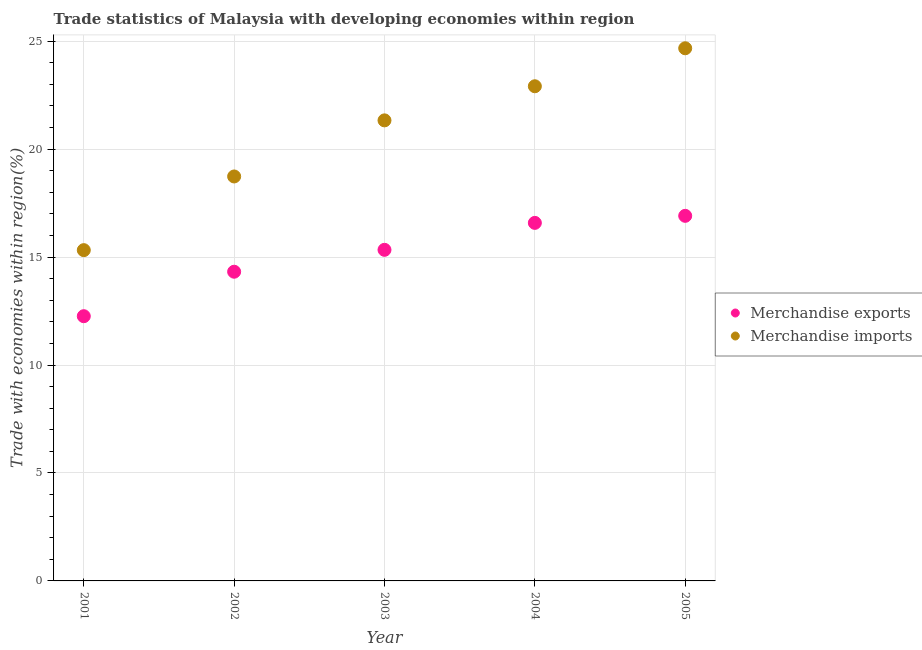Is the number of dotlines equal to the number of legend labels?
Your answer should be compact. Yes. What is the merchandise exports in 2003?
Give a very brief answer. 15.33. Across all years, what is the maximum merchandise imports?
Ensure brevity in your answer.  24.67. Across all years, what is the minimum merchandise exports?
Offer a terse response. 12.26. In which year was the merchandise imports maximum?
Provide a succinct answer. 2005. What is the total merchandise exports in the graph?
Your answer should be very brief. 75.41. What is the difference between the merchandise exports in 2002 and that in 2005?
Your answer should be very brief. -2.59. What is the difference between the merchandise imports in 2004 and the merchandise exports in 2005?
Keep it short and to the point. 6. What is the average merchandise imports per year?
Make the answer very short. 20.59. In the year 2001, what is the difference between the merchandise imports and merchandise exports?
Your answer should be compact. 3.06. What is the ratio of the merchandise exports in 2002 to that in 2004?
Provide a succinct answer. 0.86. Is the merchandise exports in 2003 less than that in 2005?
Your answer should be compact. Yes. What is the difference between the highest and the second highest merchandise exports?
Your response must be concise. 0.33. What is the difference between the highest and the lowest merchandise imports?
Provide a succinct answer. 9.35. In how many years, is the merchandise imports greater than the average merchandise imports taken over all years?
Ensure brevity in your answer.  3. Is the merchandise exports strictly greater than the merchandise imports over the years?
Provide a succinct answer. No. How many years are there in the graph?
Ensure brevity in your answer.  5. Are the values on the major ticks of Y-axis written in scientific E-notation?
Ensure brevity in your answer.  No. Does the graph contain any zero values?
Ensure brevity in your answer.  No. Where does the legend appear in the graph?
Keep it short and to the point. Center right. What is the title of the graph?
Ensure brevity in your answer.  Trade statistics of Malaysia with developing economies within region. What is the label or title of the X-axis?
Provide a short and direct response. Year. What is the label or title of the Y-axis?
Ensure brevity in your answer.  Trade with economies within region(%). What is the Trade with economies within region(%) in Merchandise exports in 2001?
Make the answer very short. 12.26. What is the Trade with economies within region(%) of Merchandise imports in 2001?
Your answer should be very brief. 15.32. What is the Trade with economies within region(%) in Merchandise exports in 2002?
Give a very brief answer. 14.32. What is the Trade with economies within region(%) in Merchandise imports in 2002?
Your answer should be very brief. 18.73. What is the Trade with economies within region(%) in Merchandise exports in 2003?
Provide a short and direct response. 15.33. What is the Trade with economies within region(%) in Merchandise imports in 2003?
Provide a succinct answer. 21.33. What is the Trade with economies within region(%) of Merchandise exports in 2004?
Keep it short and to the point. 16.58. What is the Trade with economies within region(%) of Merchandise imports in 2004?
Provide a succinct answer. 22.91. What is the Trade with economies within region(%) in Merchandise exports in 2005?
Offer a very short reply. 16.91. What is the Trade with economies within region(%) in Merchandise imports in 2005?
Ensure brevity in your answer.  24.67. Across all years, what is the maximum Trade with economies within region(%) in Merchandise exports?
Offer a very short reply. 16.91. Across all years, what is the maximum Trade with economies within region(%) of Merchandise imports?
Offer a terse response. 24.67. Across all years, what is the minimum Trade with economies within region(%) in Merchandise exports?
Give a very brief answer. 12.26. Across all years, what is the minimum Trade with economies within region(%) of Merchandise imports?
Provide a succinct answer. 15.32. What is the total Trade with economies within region(%) of Merchandise exports in the graph?
Your response must be concise. 75.41. What is the total Trade with economies within region(%) in Merchandise imports in the graph?
Give a very brief answer. 102.96. What is the difference between the Trade with economies within region(%) of Merchandise exports in 2001 and that in 2002?
Your response must be concise. -2.06. What is the difference between the Trade with economies within region(%) of Merchandise imports in 2001 and that in 2002?
Offer a very short reply. -3.41. What is the difference between the Trade with economies within region(%) in Merchandise exports in 2001 and that in 2003?
Keep it short and to the point. -3.07. What is the difference between the Trade with economies within region(%) in Merchandise imports in 2001 and that in 2003?
Offer a terse response. -6.01. What is the difference between the Trade with economies within region(%) in Merchandise exports in 2001 and that in 2004?
Your response must be concise. -4.32. What is the difference between the Trade with economies within region(%) in Merchandise imports in 2001 and that in 2004?
Your answer should be compact. -7.59. What is the difference between the Trade with economies within region(%) of Merchandise exports in 2001 and that in 2005?
Keep it short and to the point. -4.65. What is the difference between the Trade with economies within region(%) of Merchandise imports in 2001 and that in 2005?
Ensure brevity in your answer.  -9.35. What is the difference between the Trade with economies within region(%) in Merchandise exports in 2002 and that in 2003?
Your answer should be very brief. -1.01. What is the difference between the Trade with economies within region(%) of Merchandise imports in 2002 and that in 2003?
Make the answer very short. -2.6. What is the difference between the Trade with economies within region(%) of Merchandise exports in 2002 and that in 2004?
Your answer should be very brief. -2.26. What is the difference between the Trade with economies within region(%) of Merchandise imports in 2002 and that in 2004?
Make the answer very short. -4.18. What is the difference between the Trade with economies within region(%) in Merchandise exports in 2002 and that in 2005?
Provide a short and direct response. -2.59. What is the difference between the Trade with economies within region(%) of Merchandise imports in 2002 and that in 2005?
Your answer should be compact. -5.94. What is the difference between the Trade with economies within region(%) of Merchandise exports in 2003 and that in 2004?
Provide a succinct answer. -1.25. What is the difference between the Trade with economies within region(%) in Merchandise imports in 2003 and that in 2004?
Your answer should be compact. -1.58. What is the difference between the Trade with economies within region(%) in Merchandise exports in 2003 and that in 2005?
Your response must be concise. -1.57. What is the difference between the Trade with economies within region(%) of Merchandise imports in 2003 and that in 2005?
Your answer should be compact. -3.34. What is the difference between the Trade with economies within region(%) of Merchandise exports in 2004 and that in 2005?
Give a very brief answer. -0.33. What is the difference between the Trade with economies within region(%) of Merchandise imports in 2004 and that in 2005?
Your answer should be compact. -1.76. What is the difference between the Trade with economies within region(%) of Merchandise exports in 2001 and the Trade with economies within region(%) of Merchandise imports in 2002?
Keep it short and to the point. -6.47. What is the difference between the Trade with economies within region(%) in Merchandise exports in 2001 and the Trade with economies within region(%) in Merchandise imports in 2003?
Your answer should be compact. -9.07. What is the difference between the Trade with economies within region(%) in Merchandise exports in 2001 and the Trade with economies within region(%) in Merchandise imports in 2004?
Offer a terse response. -10.65. What is the difference between the Trade with economies within region(%) in Merchandise exports in 2001 and the Trade with economies within region(%) in Merchandise imports in 2005?
Ensure brevity in your answer.  -12.41. What is the difference between the Trade with economies within region(%) of Merchandise exports in 2002 and the Trade with economies within region(%) of Merchandise imports in 2003?
Offer a terse response. -7.01. What is the difference between the Trade with economies within region(%) in Merchandise exports in 2002 and the Trade with economies within region(%) in Merchandise imports in 2004?
Make the answer very short. -8.59. What is the difference between the Trade with economies within region(%) of Merchandise exports in 2002 and the Trade with economies within region(%) of Merchandise imports in 2005?
Offer a very short reply. -10.35. What is the difference between the Trade with economies within region(%) in Merchandise exports in 2003 and the Trade with economies within region(%) in Merchandise imports in 2004?
Provide a short and direct response. -7.58. What is the difference between the Trade with economies within region(%) in Merchandise exports in 2003 and the Trade with economies within region(%) in Merchandise imports in 2005?
Provide a succinct answer. -9.34. What is the difference between the Trade with economies within region(%) in Merchandise exports in 2004 and the Trade with economies within region(%) in Merchandise imports in 2005?
Give a very brief answer. -8.09. What is the average Trade with economies within region(%) in Merchandise exports per year?
Ensure brevity in your answer.  15.08. What is the average Trade with economies within region(%) in Merchandise imports per year?
Your answer should be compact. 20.59. In the year 2001, what is the difference between the Trade with economies within region(%) in Merchandise exports and Trade with economies within region(%) in Merchandise imports?
Provide a succinct answer. -3.06. In the year 2002, what is the difference between the Trade with economies within region(%) of Merchandise exports and Trade with economies within region(%) of Merchandise imports?
Your answer should be compact. -4.41. In the year 2003, what is the difference between the Trade with economies within region(%) in Merchandise exports and Trade with economies within region(%) in Merchandise imports?
Your response must be concise. -6. In the year 2004, what is the difference between the Trade with economies within region(%) in Merchandise exports and Trade with economies within region(%) in Merchandise imports?
Offer a very short reply. -6.33. In the year 2005, what is the difference between the Trade with economies within region(%) of Merchandise exports and Trade with economies within region(%) of Merchandise imports?
Offer a terse response. -7.76. What is the ratio of the Trade with economies within region(%) of Merchandise exports in 2001 to that in 2002?
Your answer should be very brief. 0.86. What is the ratio of the Trade with economies within region(%) of Merchandise imports in 2001 to that in 2002?
Provide a succinct answer. 0.82. What is the ratio of the Trade with economies within region(%) of Merchandise exports in 2001 to that in 2003?
Make the answer very short. 0.8. What is the ratio of the Trade with economies within region(%) of Merchandise imports in 2001 to that in 2003?
Give a very brief answer. 0.72. What is the ratio of the Trade with economies within region(%) of Merchandise exports in 2001 to that in 2004?
Keep it short and to the point. 0.74. What is the ratio of the Trade with economies within region(%) of Merchandise imports in 2001 to that in 2004?
Give a very brief answer. 0.67. What is the ratio of the Trade with economies within region(%) in Merchandise exports in 2001 to that in 2005?
Your response must be concise. 0.73. What is the ratio of the Trade with economies within region(%) of Merchandise imports in 2001 to that in 2005?
Your answer should be very brief. 0.62. What is the ratio of the Trade with economies within region(%) of Merchandise exports in 2002 to that in 2003?
Your response must be concise. 0.93. What is the ratio of the Trade with economies within region(%) in Merchandise imports in 2002 to that in 2003?
Provide a succinct answer. 0.88. What is the ratio of the Trade with economies within region(%) of Merchandise exports in 2002 to that in 2004?
Make the answer very short. 0.86. What is the ratio of the Trade with economies within region(%) in Merchandise imports in 2002 to that in 2004?
Your response must be concise. 0.82. What is the ratio of the Trade with economies within region(%) of Merchandise exports in 2002 to that in 2005?
Provide a succinct answer. 0.85. What is the ratio of the Trade with economies within region(%) of Merchandise imports in 2002 to that in 2005?
Your answer should be compact. 0.76. What is the ratio of the Trade with economies within region(%) of Merchandise exports in 2003 to that in 2004?
Offer a terse response. 0.92. What is the ratio of the Trade with economies within region(%) of Merchandise exports in 2003 to that in 2005?
Your response must be concise. 0.91. What is the ratio of the Trade with economies within region(%) of Merchandise imports in 2003 to that in 2005?
Offer a very short reply. 0.86. What is the ratio of the Trade with economies within region(%) in Merchandise exports in 2004 to that in 2005?
Offer a very short reply. 0.98. What is the ratio of the Trade with economies within region(%) of Merchandise imports in 2004 to that in 2005?
Your response must be concise. 0.93. What is the difference between the highest and the second highest Trade with economies within region(%) in Merchandise exports?
Give a very brief answer. 0.33. What is the difference between the highest and the second highest Trade with economies within region(%) of Merchandise imports?
Make the answer very short. 1.76. What is the difference between the highest and the lowest Trade with economies within region(%) in Merchandise exports?
Provide a succinct answer. 4.65. What is the difference between the highest and the lowest Trade with economies within region(%) of Merchandise imports?
Offer a very short reply. 9.35. 